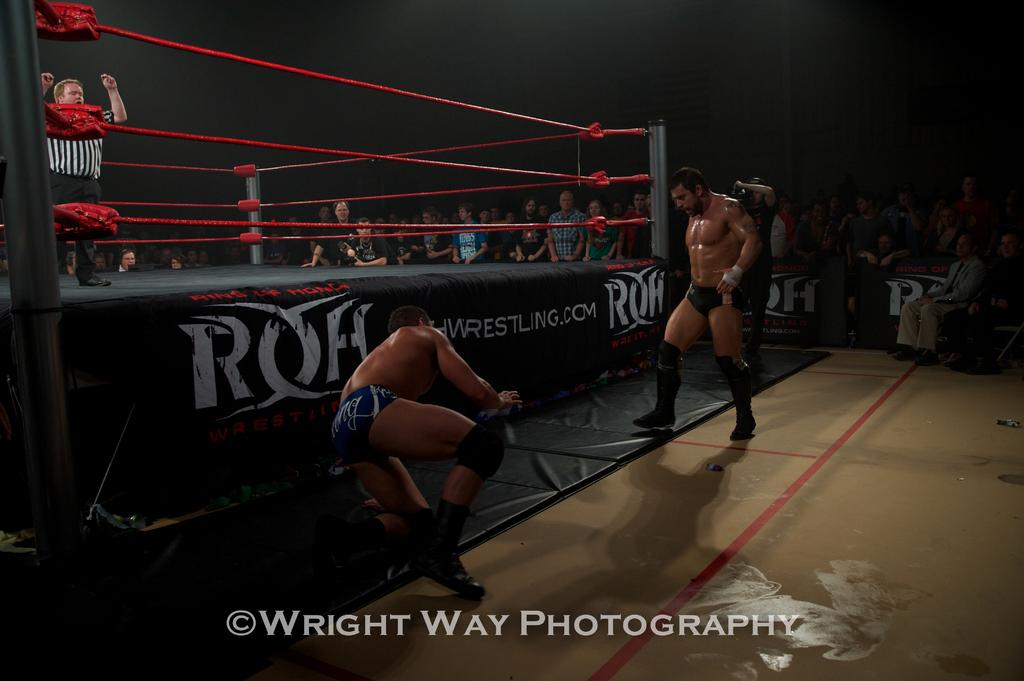Provide a one-sentence caption for the provided image. Two professional wrestlers fight outside the ring by Wright Way Photography. 